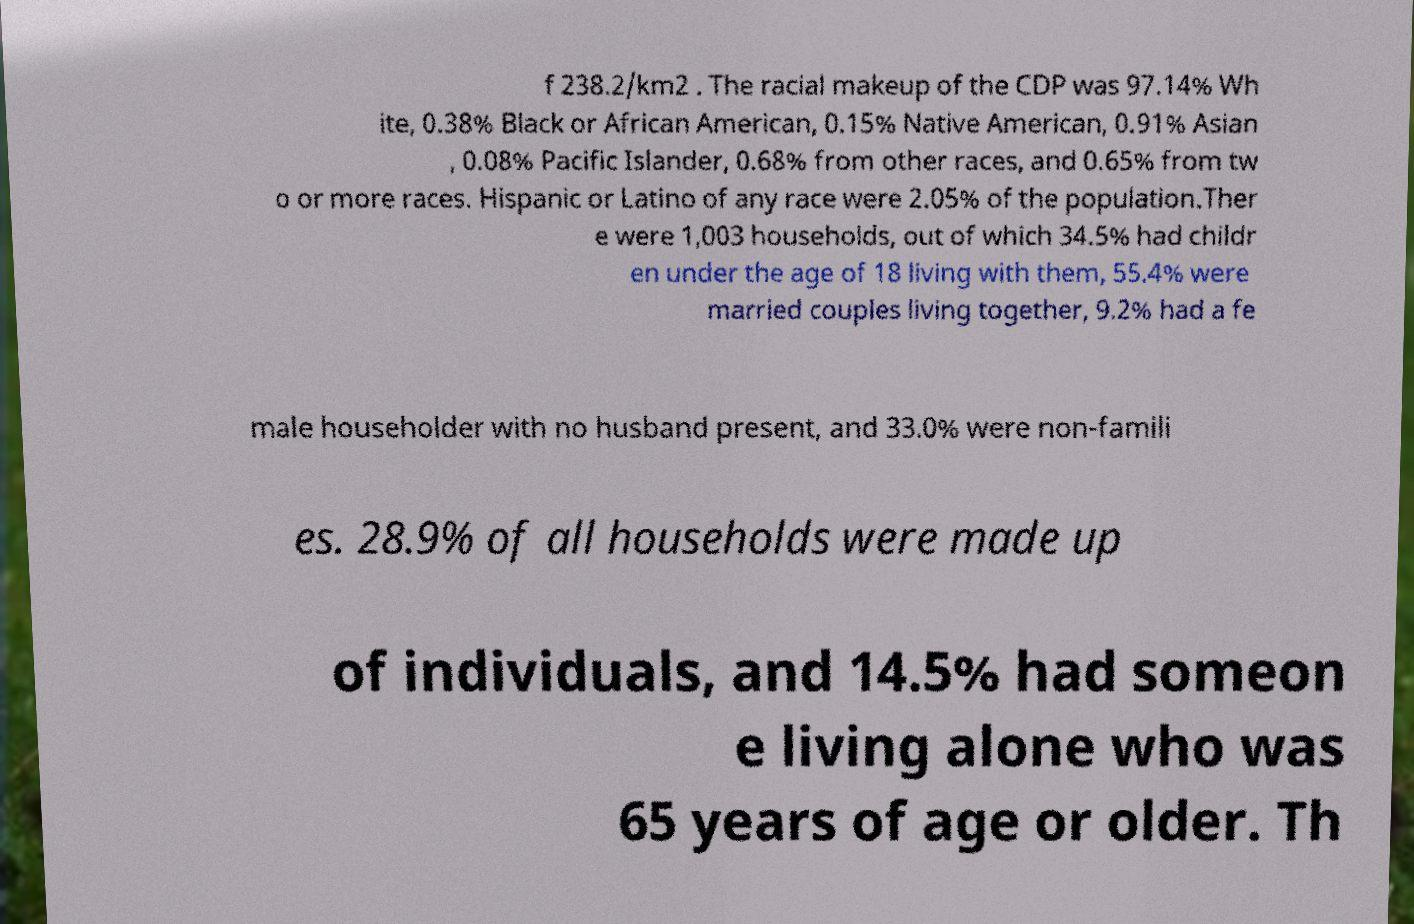Could you assist in decoding the text presented in this image and type it out clearly? f 238.2/km2 . The racial makeup of the CDP was 97.14% Wh ite, 0.38% Black or African American, 0.15% Native American, 0.91% Asian , 0.08% Pacific Islander, 0.68% from other races, and 0.65% from tw o or more races. Hispanic or Latino of any race were 2.05% of the population.Ther e were 1,003 households, out of which 34.5% had childr en under the age of 18 living with them, 55.4% were married couples living together, 9.2% had a fe male householder with no husband present, and 33.0% were non-famili es. 28.9% of all households were made up of individuals, and 14.5% had someon e living alone who was 65 years of age or older. Th 